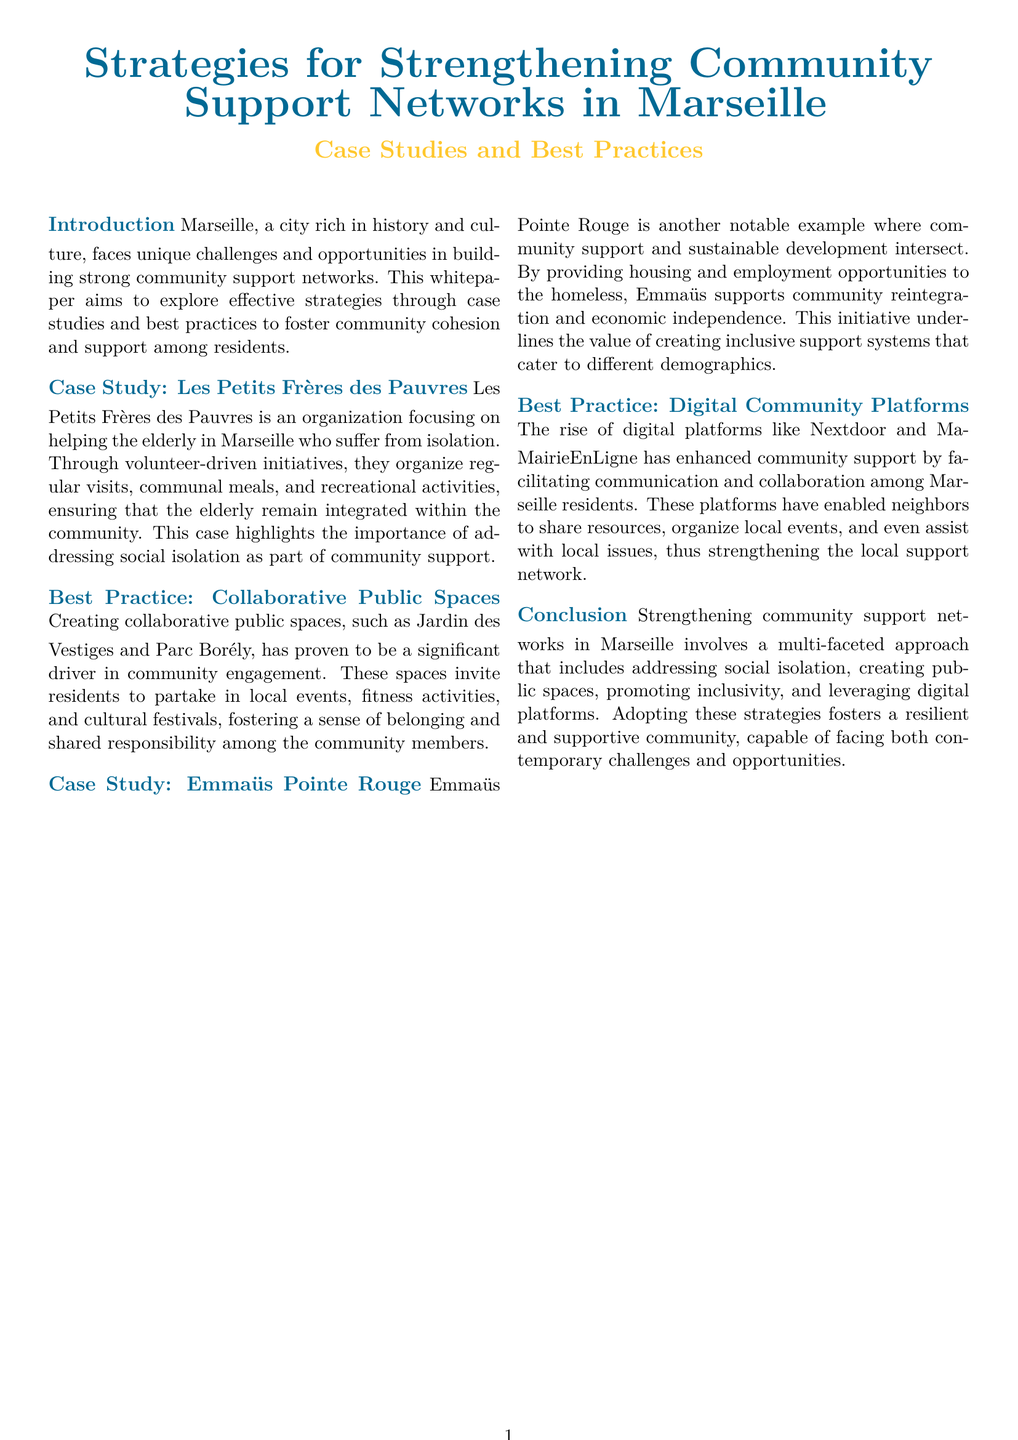what is the focus of Les Petits Frères des Pauvres? The case study details that their focus is on helping the elderly in Marseille who suffer from isolation.
Answer: helping the elderly what type of events do collaborative public spaces invite residents to partake in? The document mentions that these spaces invite residents to partake in local events, fitness activities, and cultural festivals.
Answer: local events who benefits from the initiatives of Emmaüs Pointe Rouge? The case study states that Emmaüs Pointe Rouge provides housing and employment opportunities to the homeless.
Answer: the homeless which digital platform examples are mentioned in the document? The whitepaper mentions digital platforms like Nextdoor and MaMairieEnLigne.
Answer: Nextdoor and MaMairieEnLigne what are the primary strategies discussed for strengthening community support networks? The conclusion summarizes that strategies include addressing social isolation, creating public spaces, promoting inclusivity, and leveraging digital platforms.
Answer: multi-faceted approach how does the whitepaper classify the types of best practices? The document outlines best practices which include Collaborative Public Spaces and Digital Community Platforms.
Answer: best practices what is the relationship between Emmaüs Pointe Rouge and economic independence? The case study highlights that Emmaüs supports community reintegration and economic independence.
Answer: community reintegration what is the purpose of the whitepaper? The introduction states that the purpose is to explore effective strategies through case studies and best practices to foster community cohesion and support among residents.
Answer: explore effective strategies 